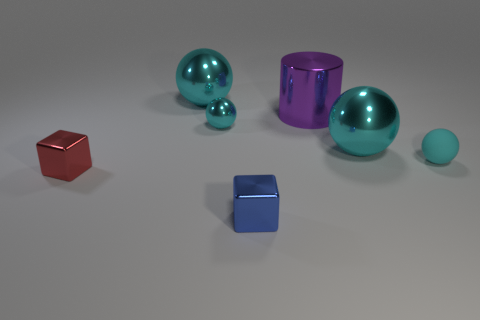Subtract all small cyan rubber balls. How many balls are left? 3 Add 1 tiny metallic balls. How many objects exist? 8 Subtract all cubes. How many objects are left? 5 Subtract 2 spheres. How many spheres are left? 2 Subtract all blue blocks. How many blocks are left? 1 Subtract all purple cubes. Subtract all gray balls. How many cubes are left? 2 Subtract all gray spheres. How many blue cylinders are left? 0 Subtract all big blue matte spheres. Subtract all red metallic objects. How many objects are left? 6 Add 2 tiny cyan things. How many tiny cyan things are left? 4 Add 3 cyan objects. How many cyan objects exist? 7 